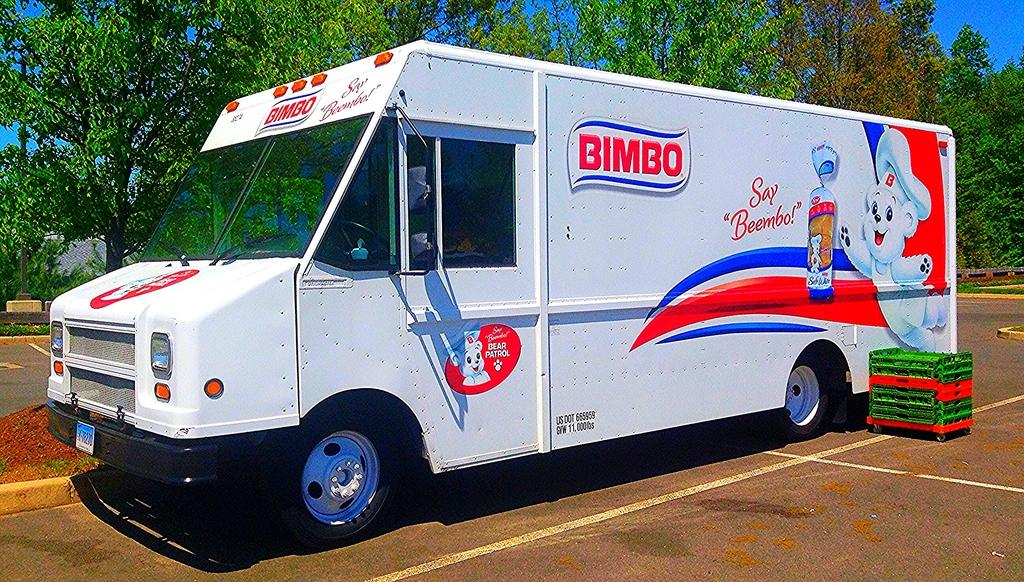What is on the road in the image? There is a vehicle on the road in the image. What can be seen beside the vehicle? There is an object beside the vehicle. What type of natural scenery is visible in the background of the image? There are trees in the background of the image. What part of the environment is visible above the trees? The sky is visible in the background of the image. How many feet are visible in the image? There are no feet visible in the image. What type of rabbit can be seen hopping in the background of the image? There is no rabbit present in the image; it only features a vehicle, an object beside it, trees, and the sky. 